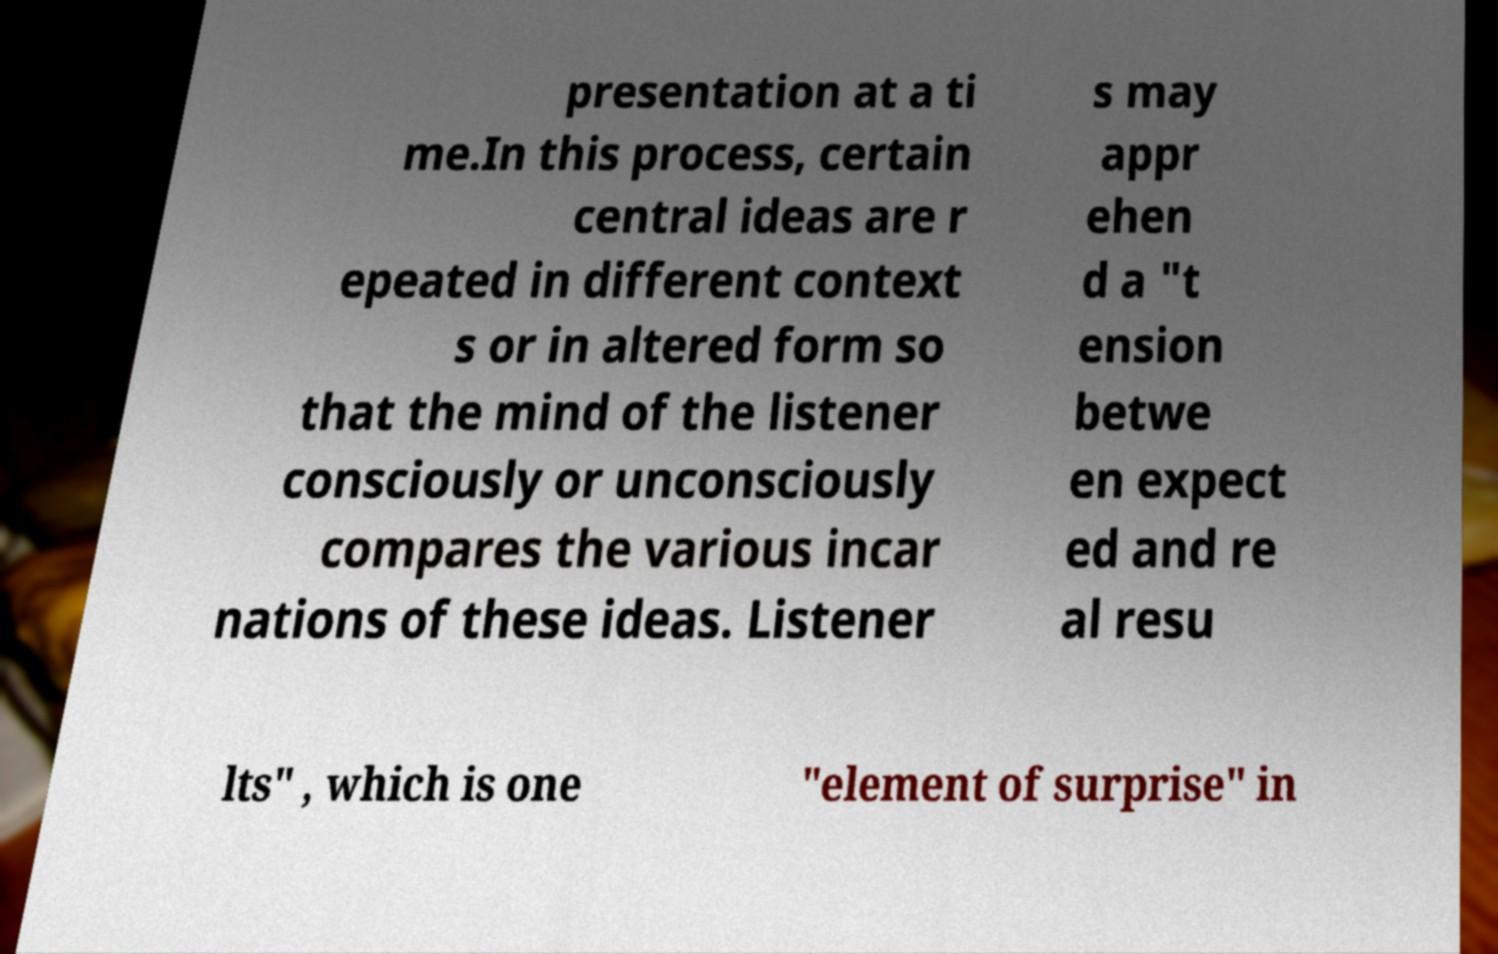I need the written content from this picture converted into text. Can you do that? presentation at a ti me.In this process, certain central ideas are r epeated in different context s or in altered form so that the mind of the listener consciously or unconsciously compares the various incar nations of these ideas. Listener s may appr ehen d a "t ension betwe en expect ed and re al resu lts" , which is one "element of surprise" in 